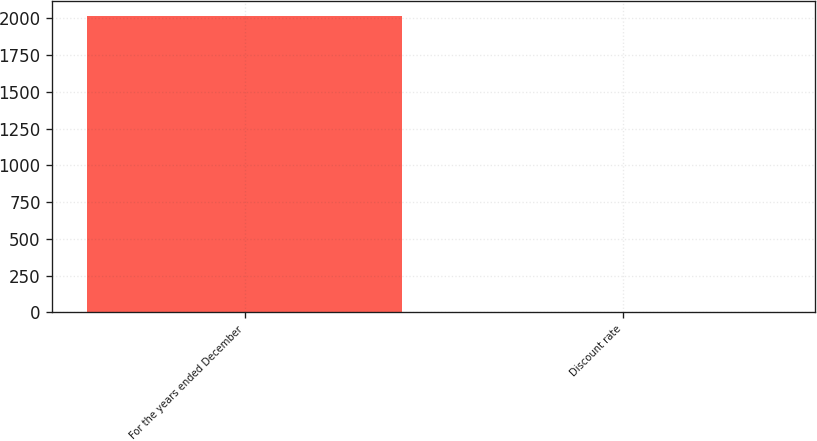Convert chart to OTSL. <chart><loc_0><loc_0><loc_500><loc_500><bar_chart><fcel>For the years ended December<fcel>Discount rate<nl><fcel>2017<fcel>3.8<nl></chart> 